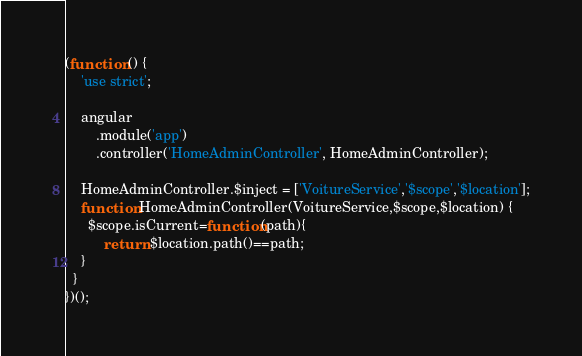<code> <loc_0><loc_0><loc_500><loc_500><_JavaScript_>(function () {
    'use strict';

    angular
        .module('app')
        .controller('HomeAdminController', HomeAdminController);

    HomeAdminController.$inject = ['VoitureService','$scope','$location'];
    function HomeAdminController(VoitureService,$scope,$location) {
      $scope.isCurrent=function(path){
          return $location.path()==path;
    }
  }
})();
</code> 